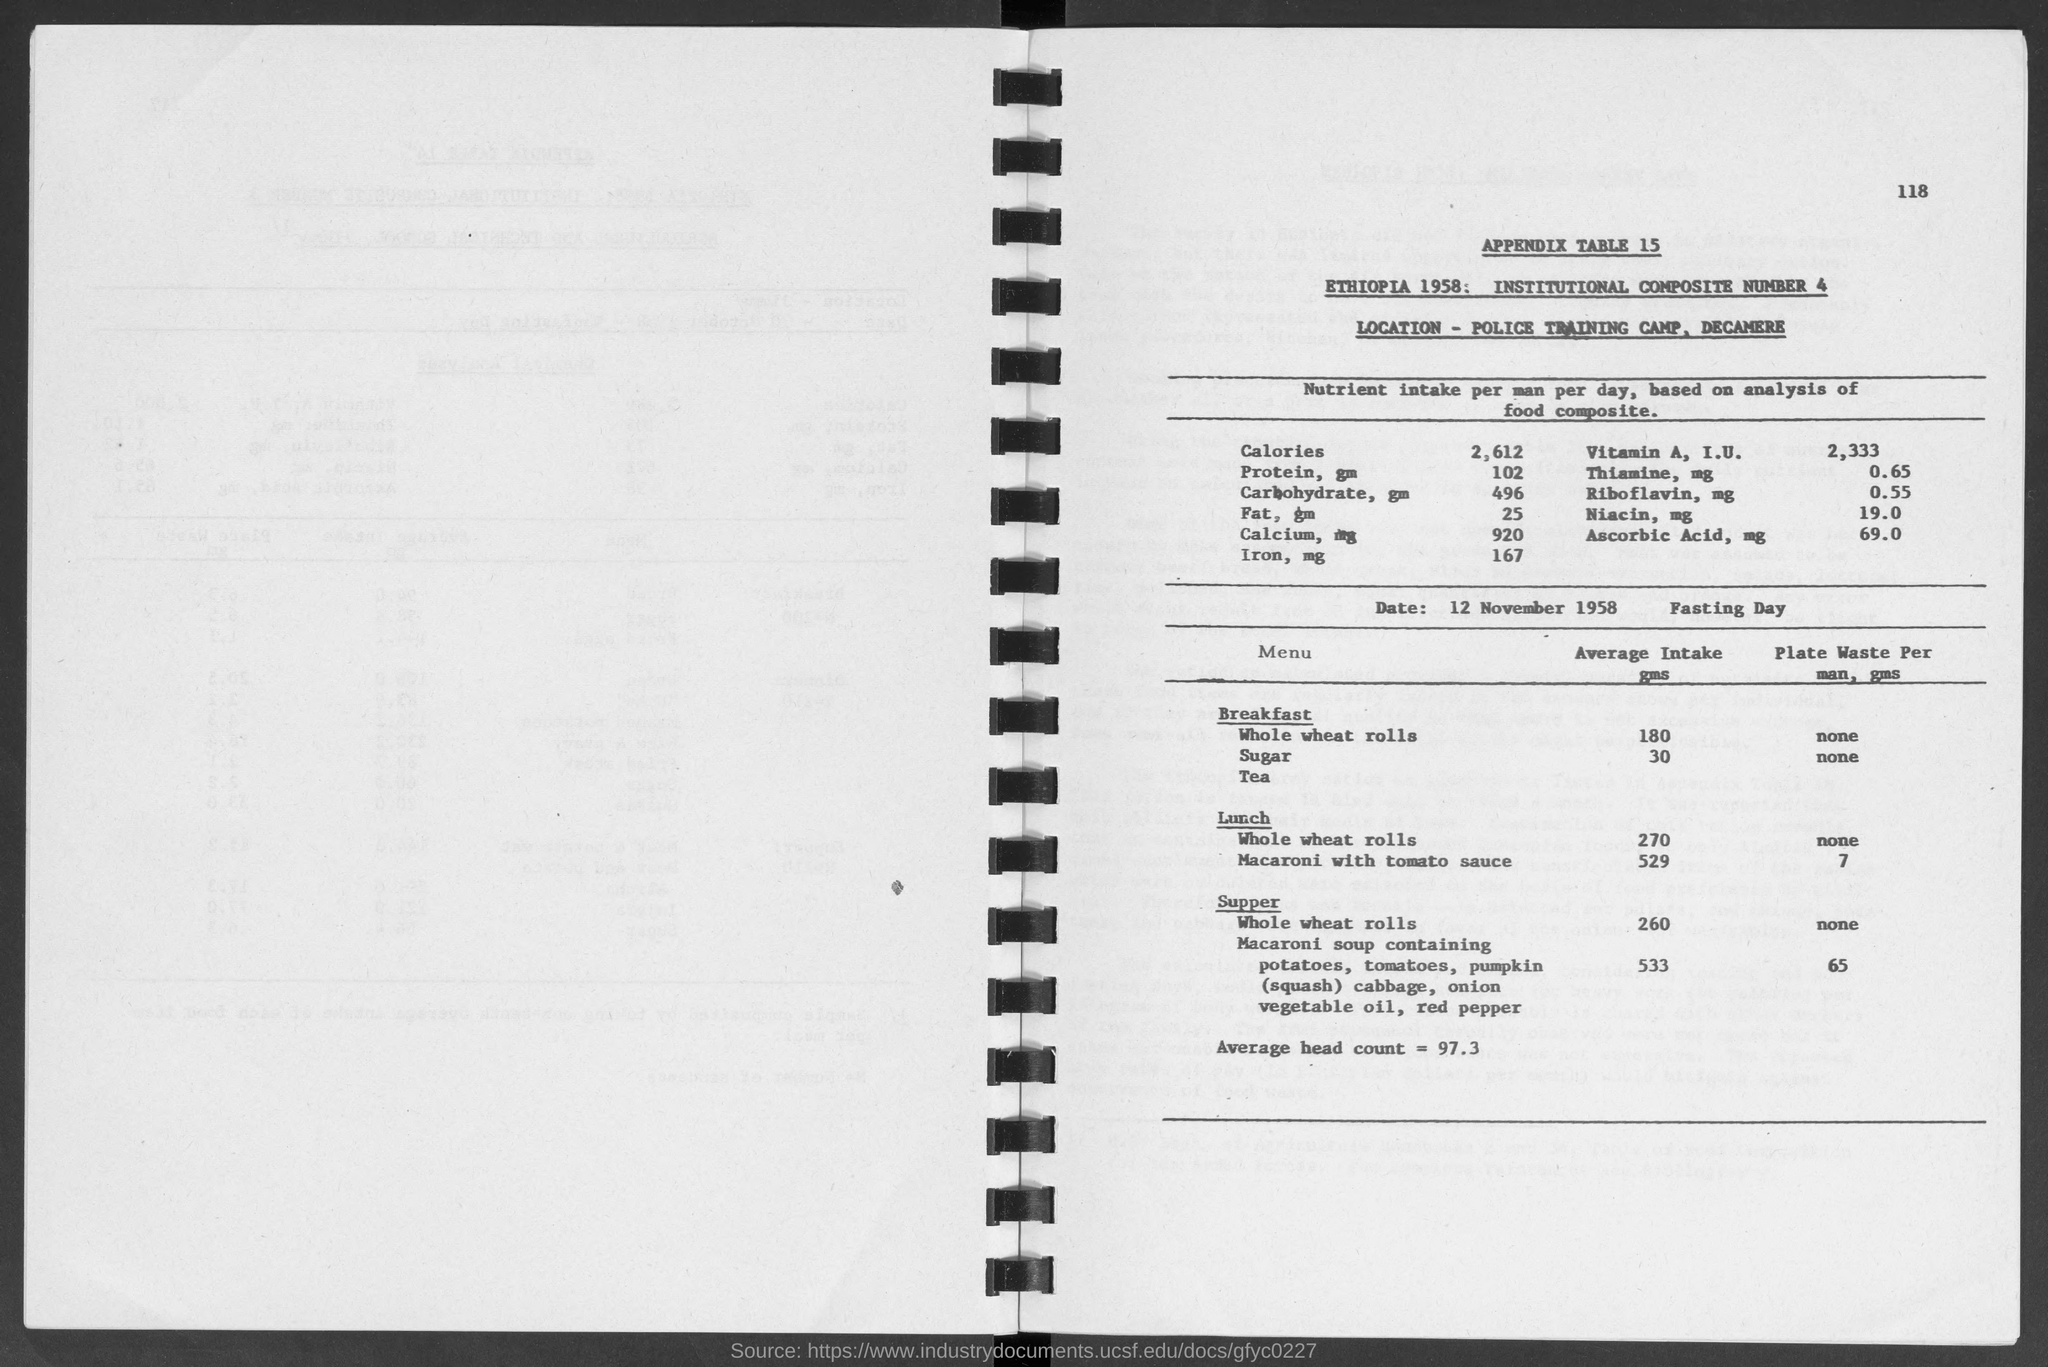What is the number at top-right corner of the page?
Your answer should be compact. 118. What is the appendix table no.?
Provide a succinct answer. 15. Where is the police training camp at?
Provide a short and direct response. Decamere. What is average head count =?
Offer a terse response. 97.3. What is the average intake of  whole wheat rolls in breakfast?
Offer a terse response. 180 gms. What is the average intake of  whole wheat rolls in lunch?
Provide a succinct answer. 270. What is the average intake of sugar in breakfast?
Provide a succinct answer. 30. What is the average intake of  whole wheat rolls in supper?
Ensure brevity in your answer.  260 gms. What is the average intake of macaroni with tomato sauce in lunch?
Your answer should be very brief. 529 gms. What is the date beside fasting day?
Make the answer very short. 12 November 1958. 